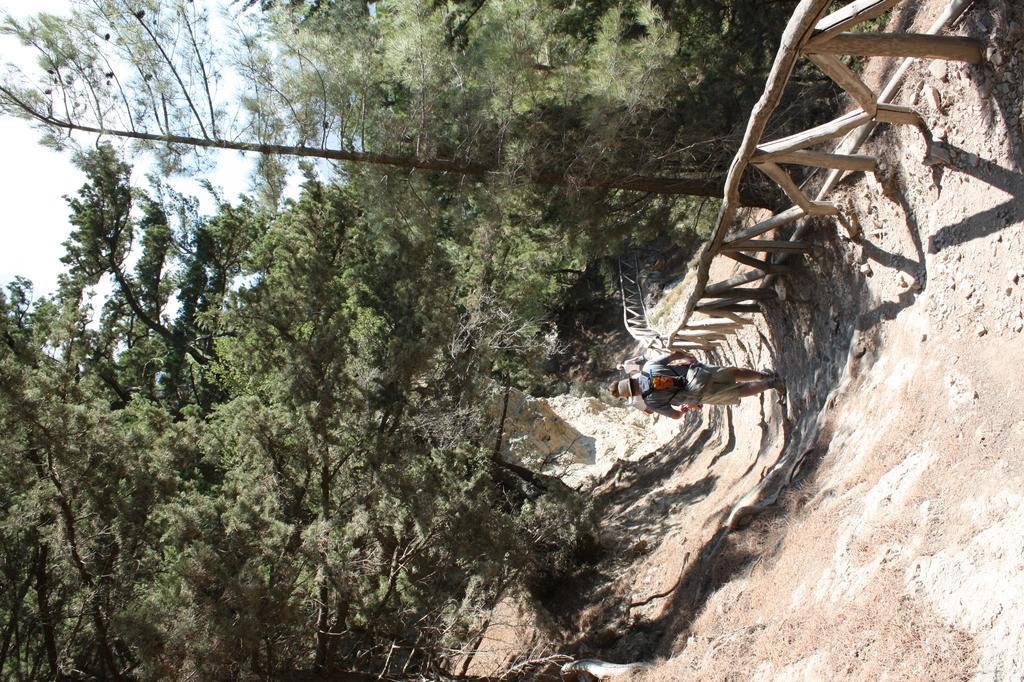How would you summarize this image in a sentence or two? In this picture we can see there are two people on the path and on the right side of the people there is a wooden fence and trees. Behind the trees there is a sky. 